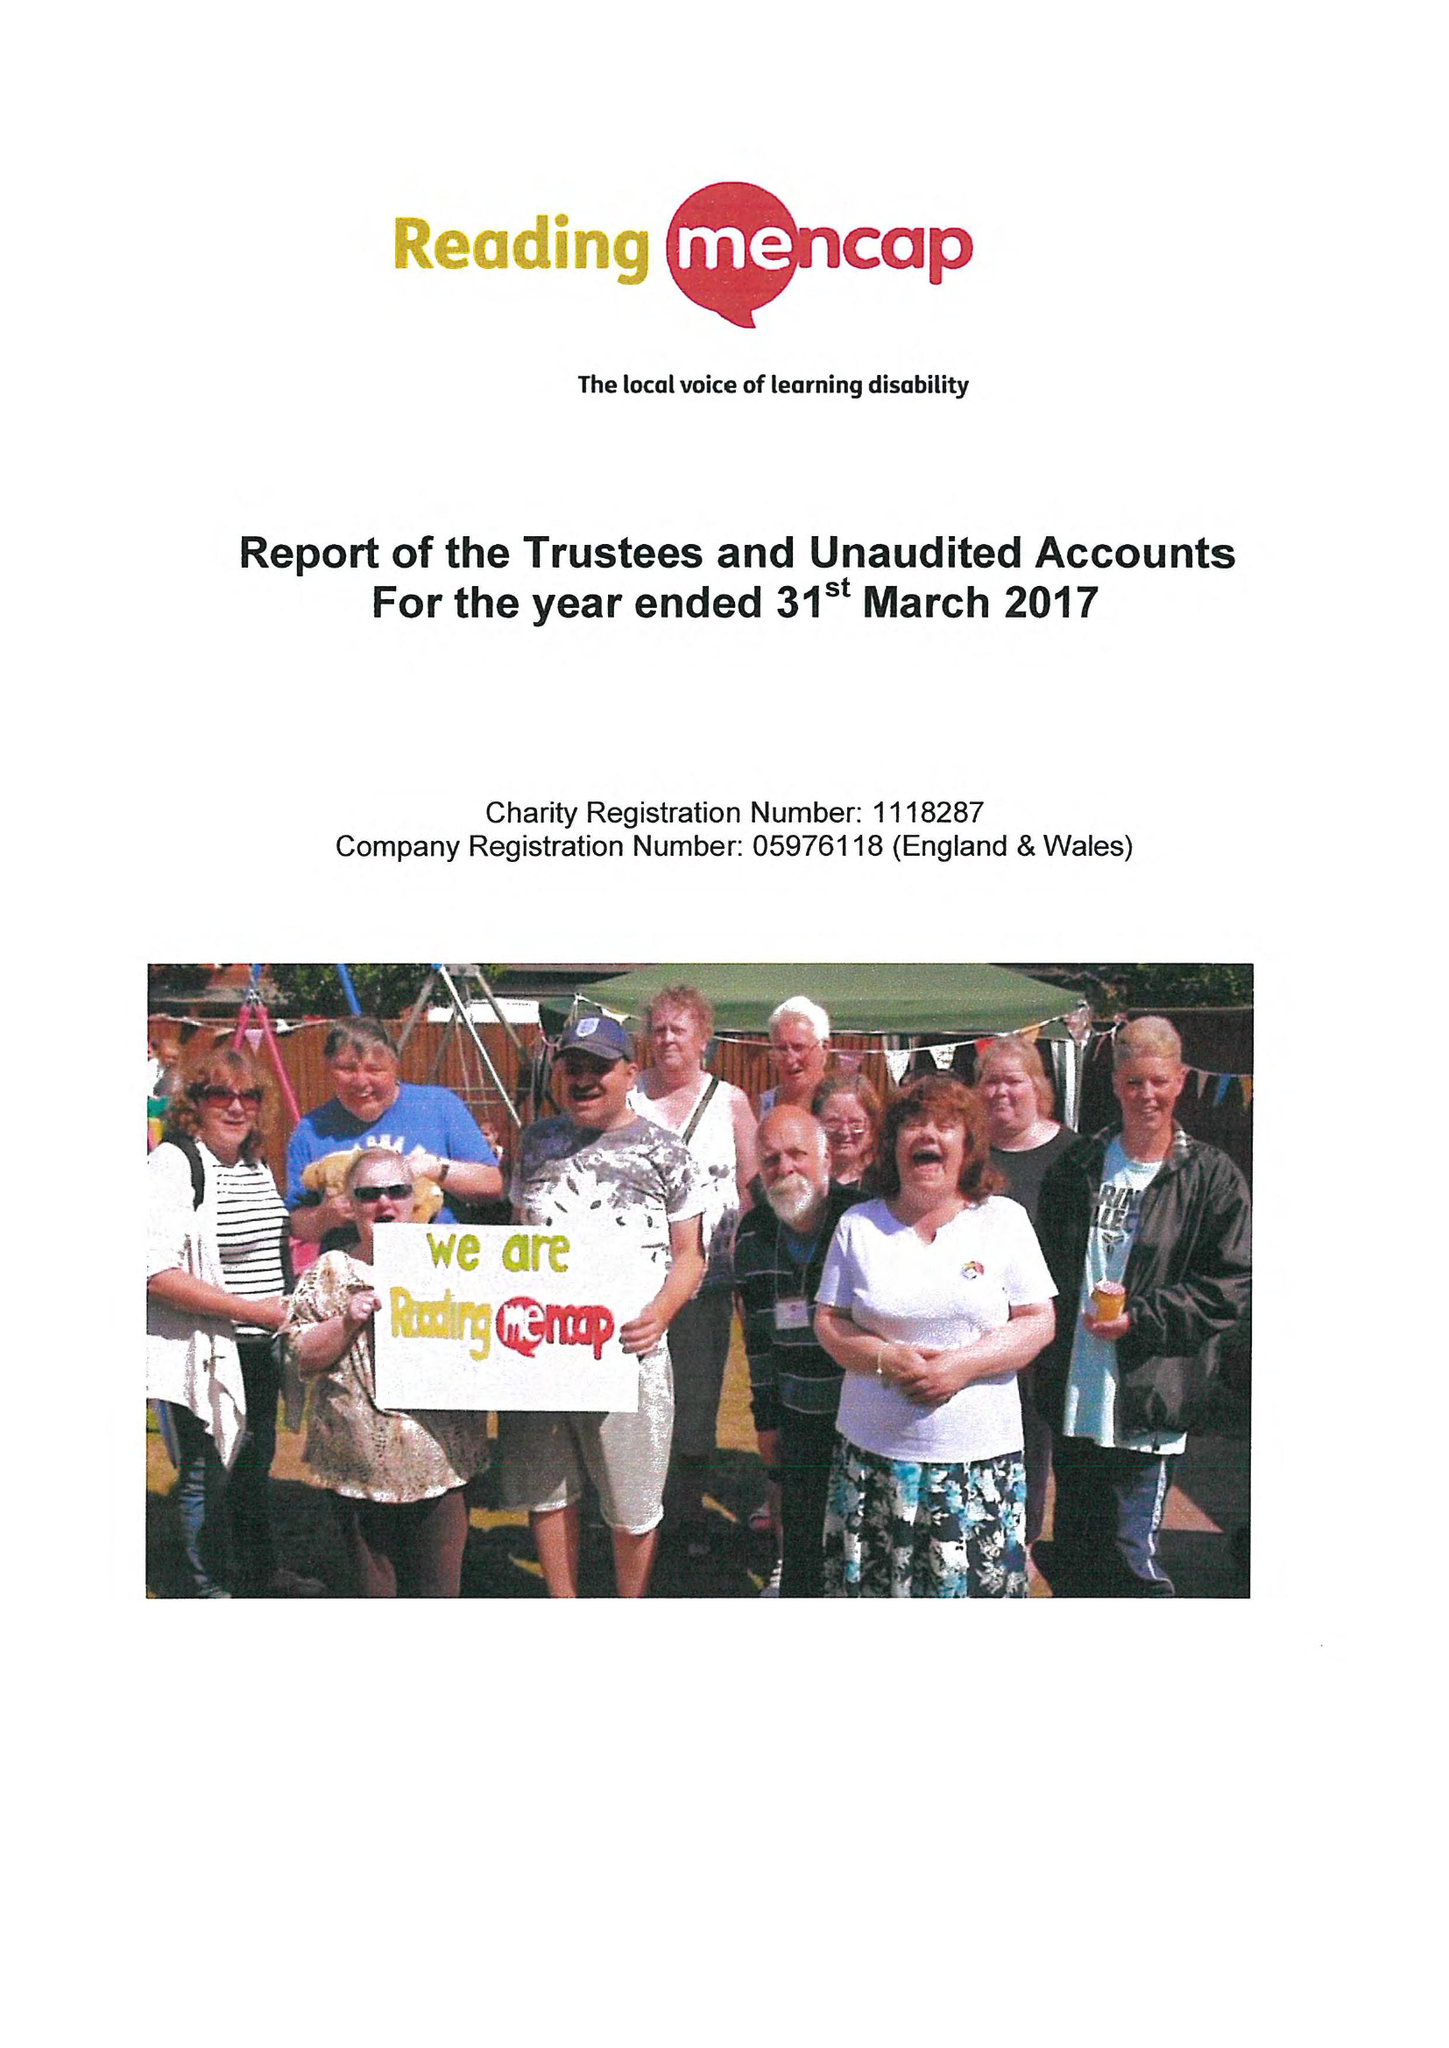What is the value for the income_annually_in_british_pounds?
Answer the question using a single word or phrase. 299339.00 